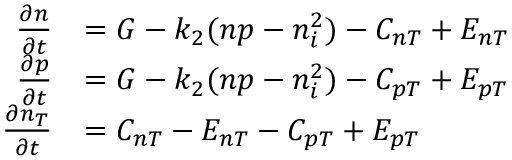Convert formula to latex. <formula><loc_0><loc_0><loc_500><loc_500>\begin{array} { r l } { \frac { \partial n } { \partial t } } & { = G - k _ { 2 } ( n p - n _ { i } ^ { 2 } ) - C _ { n T } + E _ { n T } } \\ { \frac { \partial p } { \partial t } } & { = G - k _ { 2 } ( n p - n _ { i } ^ { 2 } ) - C _ { p T } + E _ { p T } } \\ { \frac { \partial n _ { T } } { \partial t } } & { = C _ { n T } - E _ { n T } - C _ { p T } + E _ { p T } } \end{array}</formula> 